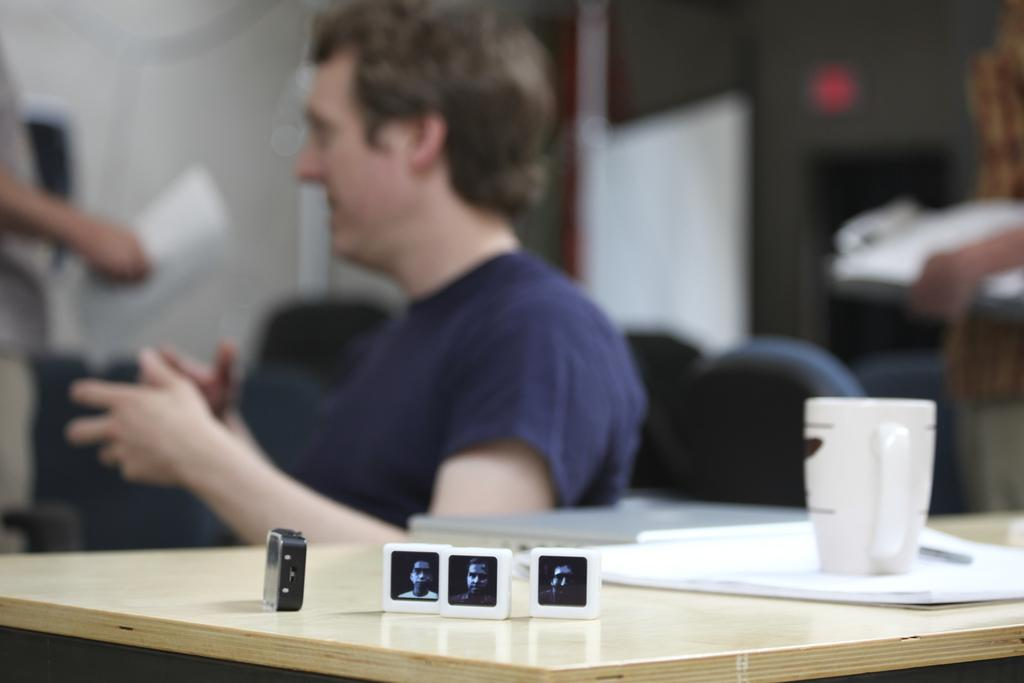What is present on the table in the image? There is an object or objects (referred to as "something's") on the table. Can you describe any other item on the table? Yes, there is a cup on the table. Is there anyone visible in the image? Yes, there is a person sitting on a chair in the background. What type of oatmeal is being served in the cup? There is no oatmeal present in the image; the cup is empty. What type of fuel is being used by the person sitting on the chair? There is no indication of any fuel being used in the image, as the person is simply sitting on a chair. 